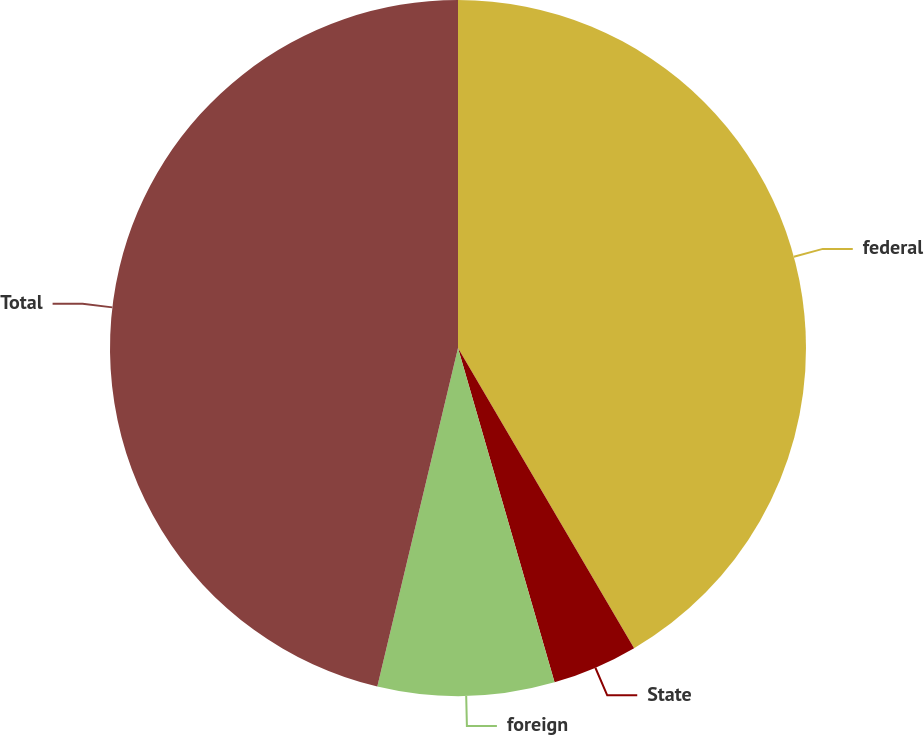Convert chart. <chart><loc_0><loc_0><loc_500><loc_500><pie_chart><fcel>federal<fcel>State<fcel>foreign<fcel>Total<nl><fcel>41.56%<fcel>3.97%<fcel>8.2%<fcel>46.28%<nl></chart> 